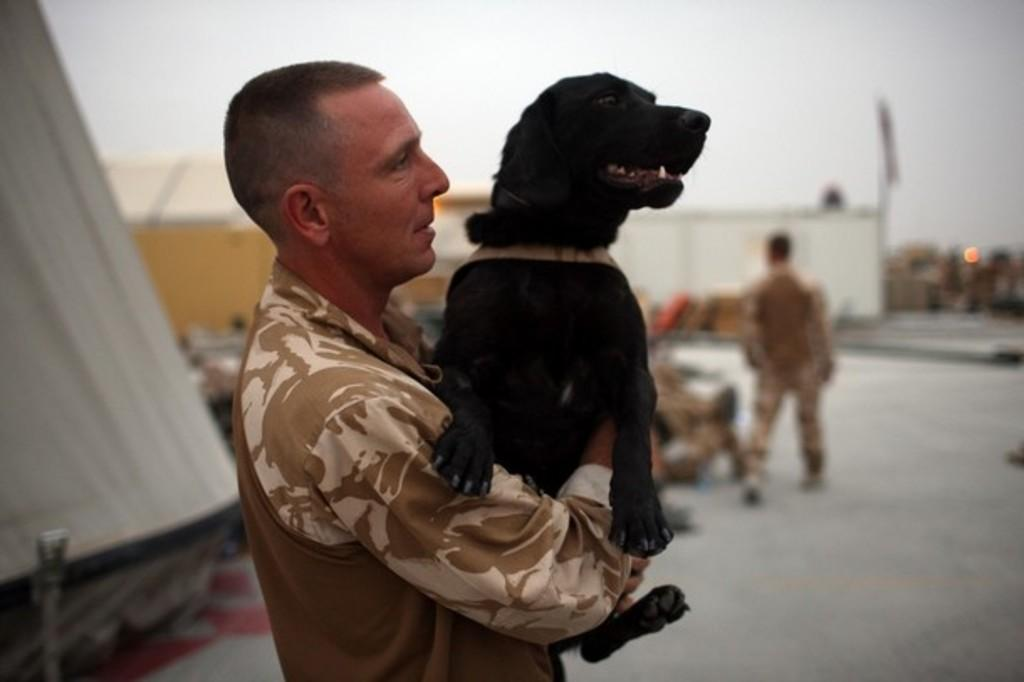Who is the main subject in the image? There is a man in the image. What is the man doing in the image? The man is holding a dog. What can be seen in the background of the image? There are men walking in the background of the image, and there is a wall with a flag attached to it. How many hearts can be seen beating in the image? There are no hearts visible in the image, as it features a man holding a dog and other elements in the background. 